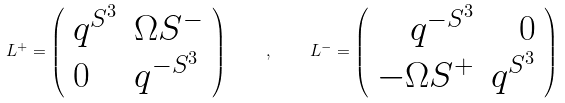Convert formula to latex. <formula><loc_0><loc_0><loc_500><loc_500>L ^ { + } = \left ( \begin{array} { l l } { { q ^ { S ^ { 3 } } } } & { { \Omega S ^ { - } } } \\ { 0 } & { { q ^ { - S ^ { 3 } } } } \end{array} \right ) \quad , \quad L ^ { - } = \left ( \begin{array} { r r } { { q ^ { - S ^ { 3 } } } } & { 0 } \\ { { - \Omega S ^ { + } } } & { { q ^ { S ^ { 3 } } } } \end{array} \right )</formula> 